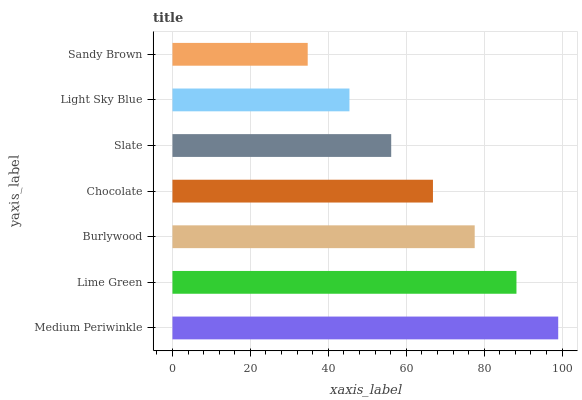Is Sandy Brown the minimum?
Answer yes or no. Yes. Is Medium Periwinkle the maximum?
Answer yes or no. Yes. Is Lime Green the minimum?
Answer yes or no. No. Is Lime Green the maximum?
Answer yes or no. No. Is Medium Periwinkle greater than Lime Green?
Answer yes or no. Yes. Is Lime Green less than Medium Periwinkle?
Answer yes or no. Yes. Is Lime Green greater than Medium Periwinkle?
Answer yes or no. No. Is Medium Periwinkle less than Lime Green?
Answer yes or no. No. Is Chocolate the high median?
Answer yes or no. Yes. Is Chocolate the low median?
Answer yes or no. Yes. Is Light Sky Blue the high median?
Answer yes or no. No. Is Medium Periwinkle the low median?
Answer yes or no. No. 